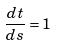Convert formula to latex. <formula><loc_0><loc_0><loc_500><loc_500>\frac { d t } { d s } = 1</formula> 